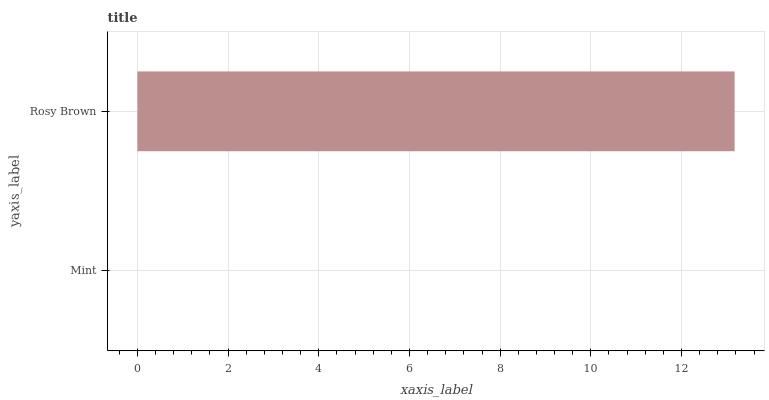Is Mint the minimum?
Answer yes or no. Yes. Is Rosy Brown the maximum?
Answer yes or no. Yes. Is Rosy Brown the minimum?
Answer yes or no. No. Is Rosy Brown greater than Mint?
Answer yes or no. Yes. Is Mint less than Rosy Brown?
Answer yes or no. Yes. Is Mint greater than Rosy Brown?
Answer yes or no. No. Is Rosy Brown less than Mint?
Answer yes or no. No. Is Rosy Brown the high median?
Answer yes or no. Yes. Is Mint the low median?
Answer yes or no. Yes. Is Mint the high median?
Answer yes or no. No. Is Rosy Brown the low median?
Answer yes or no. No. 